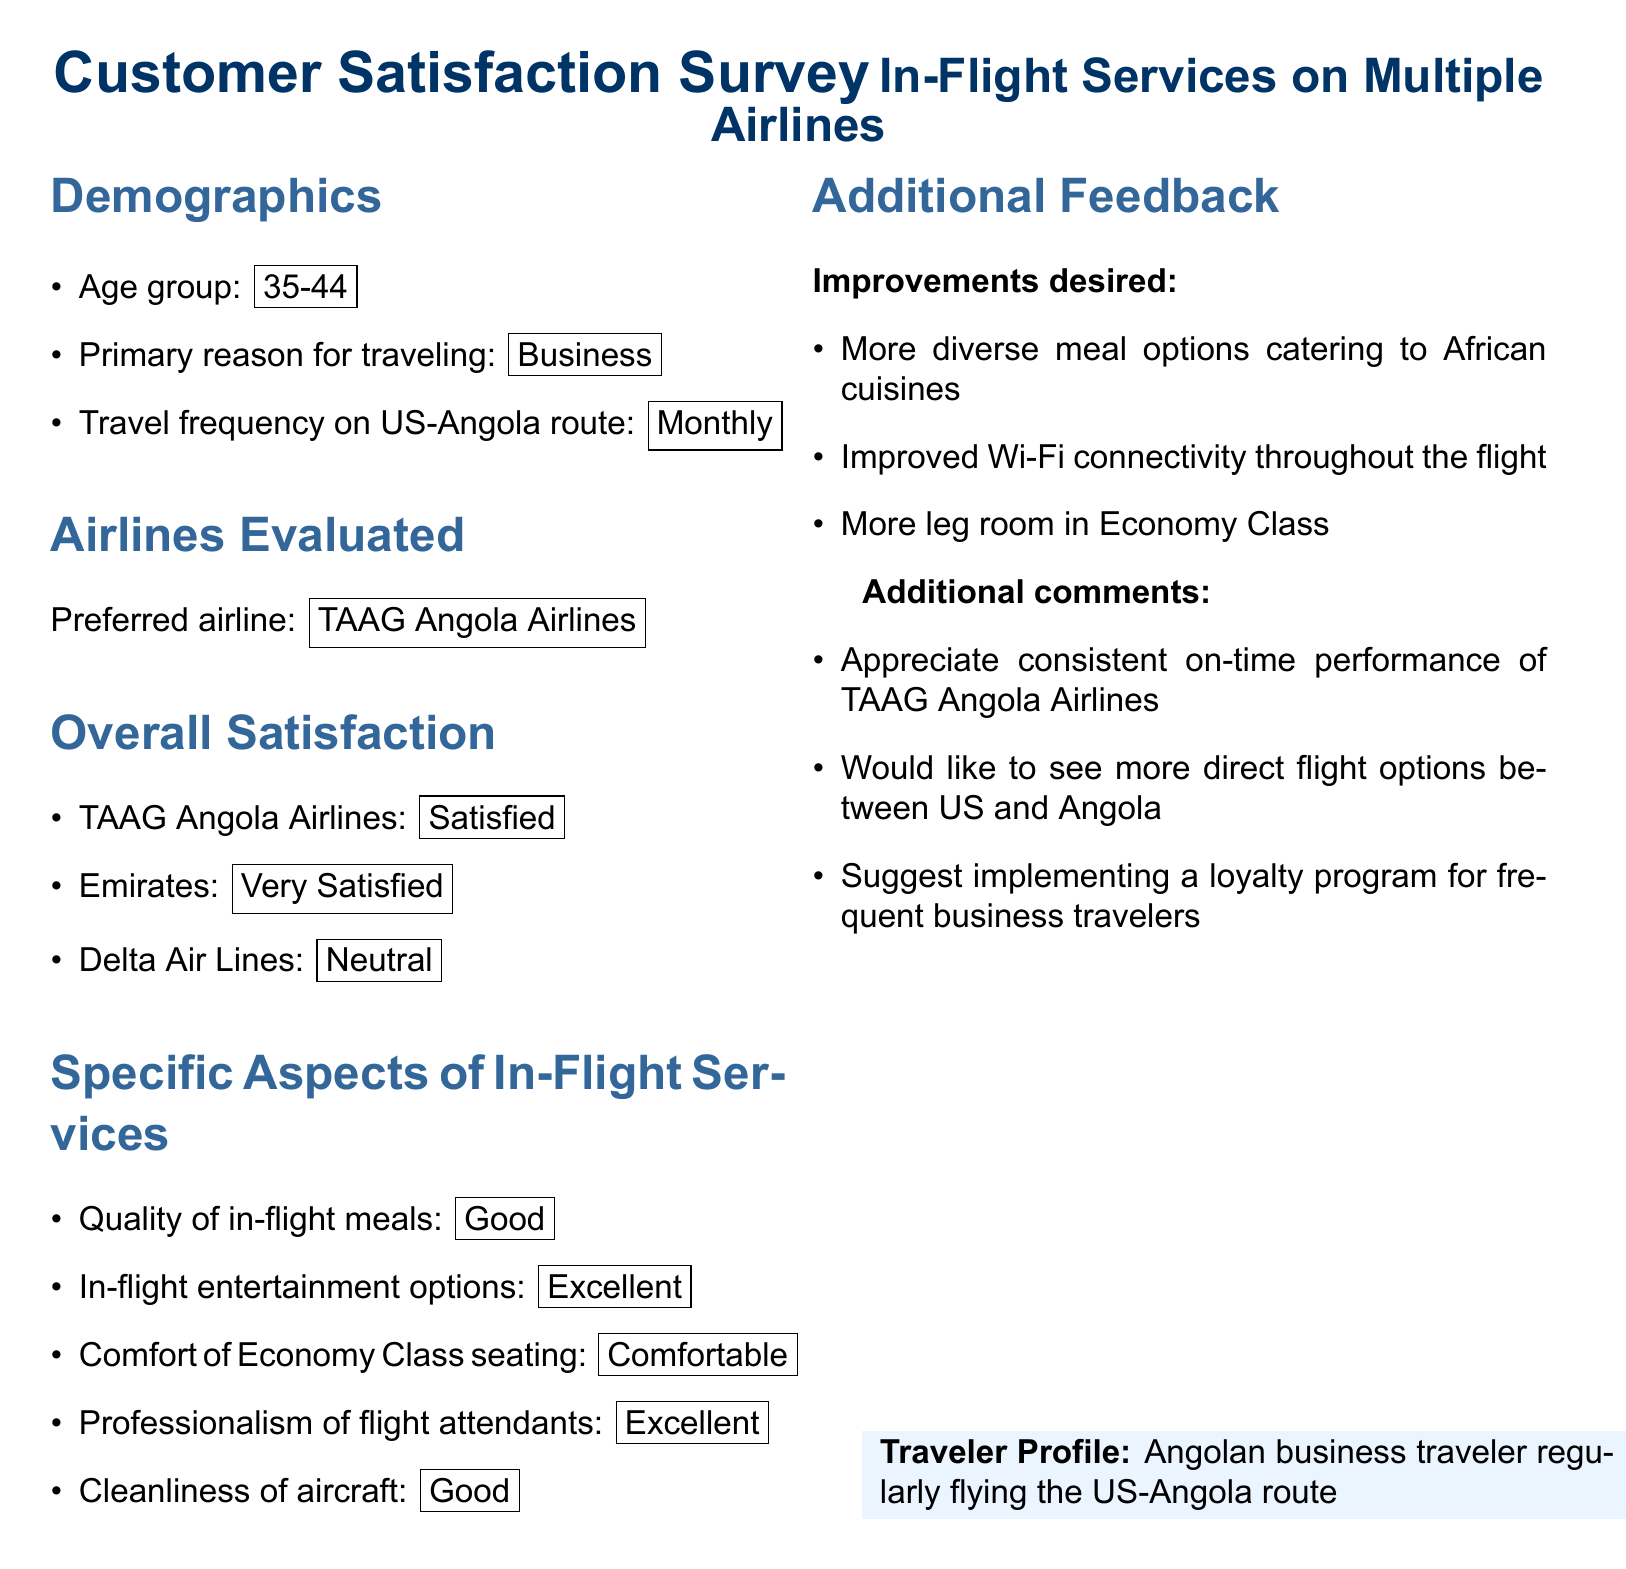What is the age group of the traveler? The age group mentioned in the document is specified in the demographics section.
Answer: 35-44 What is the primary reason for traveling? This information is pulled from the demographics section of the survey.
Answer: Business Which airline was preferred by the traveler? The preferred airline is listed in the section evaluating airlines.
Answer: TAAG Angola Airlines What was the level of satisfaction with Emirates? The satisfaction level for Emirates can be found in the overall satisfaction section.
Answer: Very Satisfied How often does the traveler fly the US-Angola route? This detail is included in the travel frequency information in the demographics.
Answer: Monthly What improvements does the traveler desire regarding meal options? The desired improvements are stated in the additional feedback section of the document.
Answer: More diverse meal options catering to African cuisines What did the traveler appreciate about TAAG Angola Airlines? This comment is found within the additional comments section that provides feedback on services.
Answer: Consistent on-time performance How did the traveler rate the professionalism of flight attendants? The rating for professionalism is present in the specific aspects of in-flight services section.
Answer: Excellent What aspect of the in-flight services was rated as 'Good'? The document lists ratings for various aspects, including this specific rating.
Answer: Quality of in-flight meals 